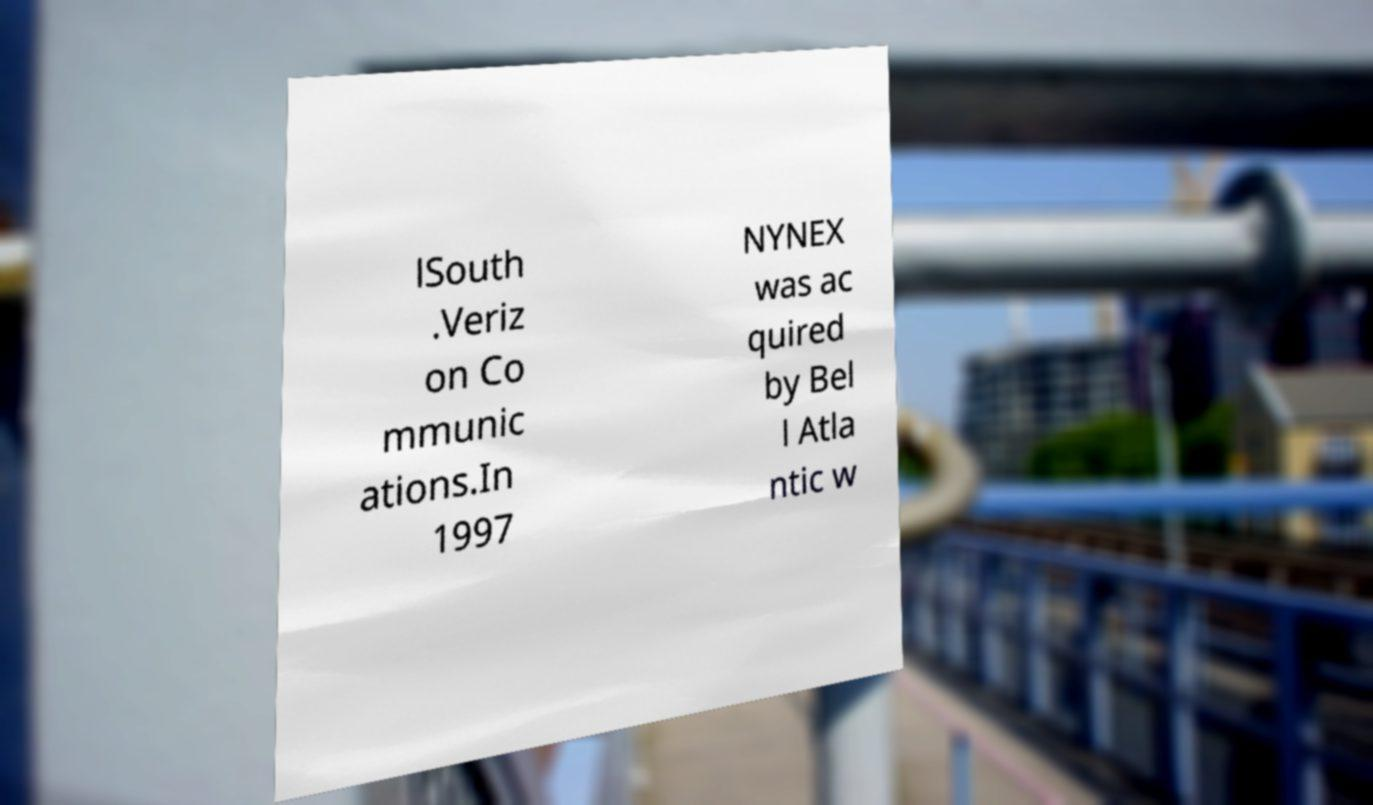There's text embedded in this image that I need extracted. Can you transcribe it verbatim? lSouth .Veriz on Co mmunic ations.In 1997 NYNEX was ac quired by Bel l Atla ntic w 